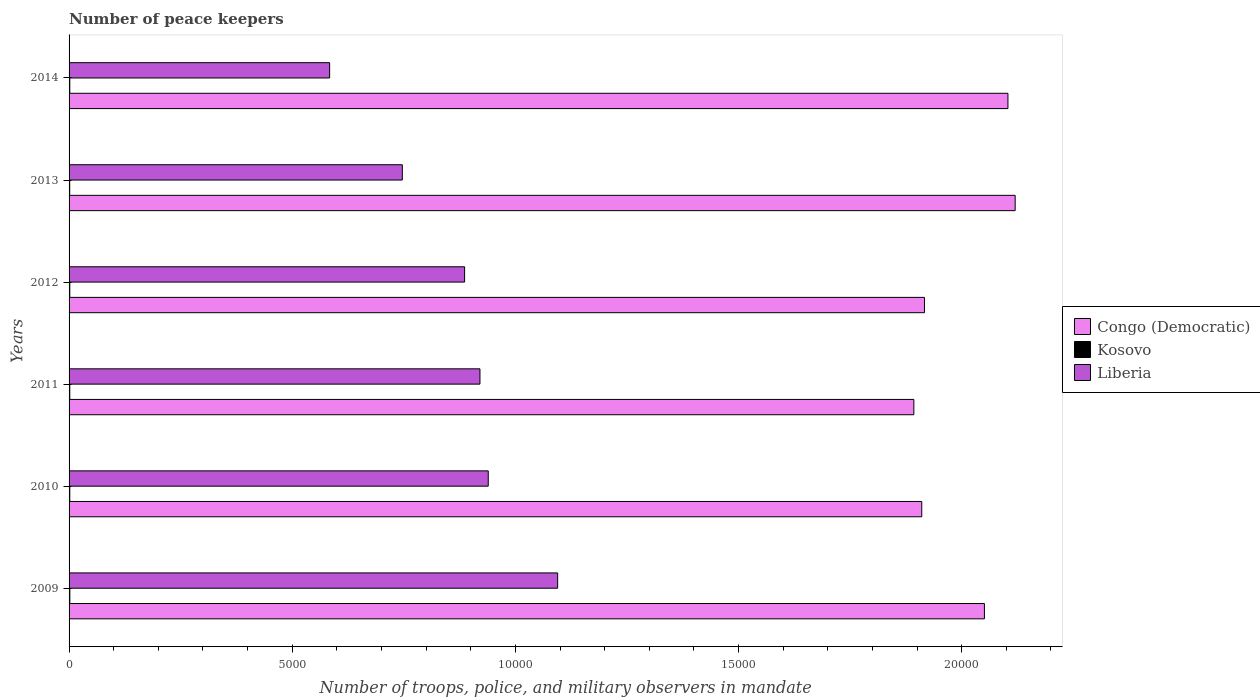Are the number of bars on each tick of the Y-axis equal?
Ensure brevity in your answer.  Yes. What is the label of the 6th group of bars from the top?
Keep it short and to the point. 2009. In how many cases, is the number of bars for a given year not equal to the number of legend labels?
Provide a succinct answer. 0. Across all years, what is the maximum number of peace keepers in in Congo (Democratic)?
Ensure brevity in your answer.  2.12e+04. Across all years, what is the minimum number of peace keepers in in Kosovo?
Offer a terse response. 14. What is the total number of peace keepers in in Kosovo in the graph?
Your response must be concise. 95. What is the difference between the number of peace keepers in in Liberia in 2009 and that in 2010?
Your answer should be compact. 1555. What is the difference between the number of peace keepers in in Liberia in 2011 and the number of peace keepers in in Congo (Democratic) in 2012?
Your answer should be compact. -9960. What is the average number of peace keepers in in Liberia per year?
Provide a succinct answer. 8618.67. In the year 2011, what is the difference between the number of peace keepers in in Kosovo and number of peace keepers in in Congo (Democratic)?
Offer a terse response. -1.89e+04. In how many years, is the number of peace keepers in in Kosovo greater than 9000 ?
Your answer should be compact. 0. What is the ratio of the number of peace keepers in in Kosovo in 2010 to that in 2013?
Your answer should be very brief. 1.14. Is the difference between the number of peace keepers in in Kosovo in 2009 and 2011 greater than the difference between the number of peace keepers in in Congo (Democratic) in 2009 and 2011?
Give a very brief answer. No. What is the difference between the highest and the lowest number of peace keepers in in Congo (Democratic)?
Make the answer very short. 2270. In how many years, is the number of peace keepers in in Congo (Democratic) greater than the average number of peace keepers in in Congo (Democratic) taken over all years?
Make the answer very short. 3. What does the 2nd bar from the top in 2013 represents?
Your answer should be very brief. Kosovo. What does the 2nd bar from the bottom in 2010 represents?
Provide a short and direct response. Kosovo. Is it the case that in every year, the sum of the number of peace keepers in in Congo (Democratic) and number of peace keepers in in Liberia is greater than the number of peace keepers in in Kosovo?
Your response must be concise. Yes. Are all the bars in the graph horizontal?
Provide a short and direct response. Yes. What is the difference between two consecutive major ticks on the X-axis?
Your response must be concise. 5000. Does the graph contain any zero values?
Offer a very short reply. No. What is the title of the graph?
Provide a succinct answer. Number of peace keepers. What is the label or title of the X-axis?
Your response must be concise. Number of troops, police, and military observers in mandate. What is the Number of troops, police, and military observers in mandate in Congo (Democratic) in 2009?
Provide a succinct answer. 2.05e+04. What is the Number of troops, police, and military observers in mandate in Liberia in 2009?
Ensure brevity in your answer.  1.09e+04. What is the Number of troops, police, and military observers in mandate of Congo (Democratic) in 2010?
Your answer should be compact. 1.91e+04. What is the Number of troops, police, and military observers in mandate in Kosovo in 2010?
Provide a succinct answer. 16. What is the Number of troops, police, and military observers in mandate of Liberia in 2010?
Give a very brief answer. 9392. What is the Number of troops, police, and military observers in mandate in Congo (Democratic) in 2011?
Give a very brief answer. 1.89e+04. What is the Number of troops, police, and military observers in mandate in Kosovo in 2011?
Ensure brevity in your answer.  16. What is the Number of troops, police, and military observers in mandate in Liberia in 2011?
Your answer should be very brief. 9206. What is the Number of troops, police, and military observers in mandate in Congo (Democratic) in 2012?
Your answer should be compact. 1.92e+04. What is the Number of troops, police, and military observers in mandate in Liberia in 2012?
Ensure brevity in your answer.  8862. What is the Number of troops, police, and military observers in mandate in Congo (Democratic) in 2013?
Your answer should be compact. 2.12e+04. What is the Number of troops, police, and military observers in mandate of Kosovo in 2013?
Your response must be concise. 14. What is the Number of troops, police, and military observers in mandate of Liberia in 2013?
Your answer should be very brief. 7467. What is the Number of troops, police, and military observers in mandate of Congo (Democratic) in 2014?
Keep it short and to the point. 2.10e+04. What is the Number of troops, police, and military observers in mandate in Kosovo in 2014?
Keep it short and to the point. 16. What is the Number of troops, police, and military observers in mandate in Liberia in 2014?
Provide a succinct answer. 5838. Across all years, what is the maximum Number of troops, police, and military observers in mandate of Congo (Democratic)?
Your answer should be compact. 2.12e+04. Across all years, what is the maximum Number of troops, police, and military observers in mandate of Kosovo?
Your answer should be very brief. 17. Across all years, what is the maximum Number of troops, police, and military observers in mandate of Liberia?
Offer a very short reply. 1.09e+04. Across all years, what is the minimum Number of troops, police, and military observers in mandate in Congo (Democratic)?
Your answer should be very brief. 1.89e+04. Across all years, what is the minimum Number of troops, police, and military observers in mandate of Liberia?
Offer a very short reply. 5838. What is the total Number of troops, police, and military observers in mandate in Congo (Democratic) in the graph?
Your answer should be compact. 1.20e+05. What is the total Number of troops, police, and military observers in mandate in Liberia in the graph?
Offer a very short reply. 5.17e+04. What is the difference between the Number of troops, police, and military observers in mandate in Congo (Democratic) in 2009 and that in 2010?
Offer a terse response. 1404. What is the difference between the Number of troops, police, and military observers in mandate of Liberia in 2009 and that in 2010?
Keep it short and to the point. 1555. What is the difference between the Number of troops, police, and military observers in mandate of Congo (Democratic) in 2009 and that in 2011?
Give a very brief answer. 1581. What is the difference between the Number of troops, police, and military observers in mandate of Kosovo in 2009 and that in 2011?
Keep it short and to the point. 1. What is the difference between the Number of troops, police, and military observers in mandate in Liberia in 2009 and that in 2011?
Give a very brief answer. 1741. What is the difference between the Number of troops, police, and military observers in mandate of Congo (Democratic) in 2009 and that in 2012?
Your response must be concise. 1343. What is the difference between the Number of troops, police, and military observers in mandate of Kosovo in 2009 and that in 2012?
Ensure brevity in your answer.  1. What is the difference between the Number of troops, police, and military observers in mandate in Liberia in 2009 and that in 2012?
Provide a short and direct response. 2085. What is the difference between the Number of troops, police, and military observers in mandate of Congo (Democratic) in 2009 and that in 2013?
Your answer should be very brief. -689. What is the difference between the Number of troops, police, and military observers in mandate of Liberia in 2009 and that in 2013?
Offer a very short reply. 3480. What is the difference between the Number of troops, police, and military observers in mandate in Congo (Democratic) in 2009 and that in 2014?
Keep it short and to the point. -527. What is the difference between the Number of troops, police, and military observers in mandate in Kosovo in 2009 and that in 2014?
Offer a terse response. 1. What is the difference between the Number of troops, police, and military observers in mandate of Liberia in 2009 and that in 2014?
Give a very brief answer. 5109. What is the difference between the Number of troops, police, and military observers in mandate of Congo (Democratic) in 2010 and that in 2011?
Keep it short and to the point. 177. What is the difference between the Number of troops, police, and military observers in mandate in Kosovo in 2010 and that in 2011?
Give a very brief answer. 0. What is the difference between the Number of troops, police, and military observers in mandate in Liberia in 2010 and that in 2011?
Provide a succinct answer. 186. What is the difference between the Number of troops, police, and military observers in mandate in Congo (Democratic) in 2010 and that in 2012?
Your response must be concise. -61. What is the difference between the Number of troops, police, and military observers in mandate in Liberia in 2010 and that in 2012?
Your response must be concise. 530. What is the difference between the Number of troops, police, and military observers in mandate in Congo (Democratic) in 2010 and that in 2013?
Your answer should be very brief. -2093. What is the difference between the Number of troops, police, and military observers in mandate of Liberia in 2010 and that in 2013?
Your answer should be compact. 1925. What is the difference between the Number of troops, police, and military observers in mandate of Congo (Democratic) in 2010 and that in 2014?
Offer a very short reply. -1931. What is the difference between the Number of troops, police, and military observers in mandate in Kosovo in 2010 and that in 2014?
Make the answer very short. 0. What is the difference between the Number of troops, police, and military observers in mandate in Liberia in 2010 and that in 2014?
Provide a succinct answer. 3554. What is the difference between the Number of troops, police, and military observers in mandate of Congo (Democratic) in 2011 and that in 2012?
Make the answer very short. -238. What is the difference between the Number of troops, police, and military observers in mandate in Kosovo in 2011 and that in 2012?
Give a very brief answer. 0. What is the difference between the Number of troops, police, and military observers in mandate in Liberia in 2011 and that in 2012?
Offer a very short reply. 344. What is the difference between the Number of troops, police, and military observers in mandate in Congo (Democratic) in 2011 and that in 2013?
Keep it short and to the point. -2270. What is the difference between the Number of troops, police, and military observers in mandate in Liberia in 2011 and that in 2013?
Your response must be concise. 1739. What is the difference between the Number of troops, police, and military observers in mandate of Congo (Democratic) in 2011 and that in 2014?
Offer a terse response. -2108. What is the difference between the Number of troops, police, and military observers in mandate in Kosovo in 2011 and that in 2014?
Provide a short and direct response. 0. What is the difference between the Number of troops, police, and military observers in mandate of Liberia in 2011 and that in 2014?
Your answer should be compact. 3368. What is the difference between the Number of troops, police, and military observers in mandate in Congo (Democratic) in 2012 and that in 2013?
Your response must be concise. -2032. What is the difference between the Number of troops, police, and military observers in mandate in Liberia in 2012 and that in 2013?
Keep it short and to the point. 1395. What is the difference between the Number of troops, police, and military observers in mandate of Congo (Democratic) in 2012 and that in 2014?
Provide a succinct answer. -1870. What is the difference between the Number of troops, police, and military observers in mandate of Kosovo in 2012 and that in 2014?
Provide a succinct answer. 0. What is the difference between the Number of troops, police, and military observers in mandate of Liberia in 2012 and that in 2014?
Your answer should be compact. 3024. What is the difference between the Number of troops, police, and military observers in mandate in Congo (Democratic) in 2013 and that in 2014?
Offer a terse response. 162. What is the difference between the Number of troops, police, and military observers in mandate of Liberia in 2013 and that in 2014?
Give a very brief answer. 1629. What is the difference between the Number of troops, police, and military observers in mandate in Congo (Democratic) in 2009 and the Number of troops, police, and military observers in mandate in Kosovo in 2010?
Offer a very short reply. 2.05e+04. What is the difference between the Number of troops, police, and military observers in mandate of Congo (Democratic) in 2009 and the Number of troops, police, and military observers in mandate of Liberia in 2010?
Keep it short and to the point. 1.11e+04. What is the difference between the Number of troops, police, and military observers in mandate in Kosovo in 2009 and the Number of troops, police, and military observers in mandate in Liberia in 2010?
Provide a short and direct response. -9375. What is the difference between the Number of troops, police, and military observers in mandate of Congo (Democratic) in 2009 and the Number of troops, police, and military observers in mandate of Kosovo in 2011?
Provide a short and direct response. 2.05e+04. What is the difference between the Number of troops, police, and military observers in mandate of Congo (Democratic) in 2009 and the Number of troops, police, and military observers in mandate of Liberia in 2011?
Offer a very short reply. 1.13e+04. What is the difference between the Number of troops, police, and military observers in mandate in Kosovo in 2009 and the Number of troops, police, and military observers in mandate in Liberia in 2011?
Make the answer very short. -9189. What is the difference between the Number of troops, police, and military observers in mandate of Congo (Democratic) in 2009 and the Number of troops, police, and military observers in mandate of Kosovo in 2012?
Ensure brevity in your answer.  2.05e+04. What is the difference between the Number of troops, police, and military observers in mandate of Congo (Democratic) in 2009 and the Number of troops, police, and military observers in mandate of Liberia in 2012?
Offer a very short reply. 1.16e+04. What is the difference between the Number of troops, police, and military observers in mandate in Kosovo in 2009 and the Number of troops, police, and military observers in mandate in Liberia in 2012?
Give a very brief answer. -8845. What is the difference between the Number of troops, police, and military observers in mandate of Congo (Democratic) in 2009 and the Number of troops, police, and military observers in mandate of Kosovo in 2013?
Ensure brevity in your answer.  2.05e+04. What is the difference between the Number of troops, police, and military observers in mandate in Congo (Democratic) in 2009 and the Number of troops, police, and military observers in mandate in Liberia in 2013?
Offer a terse response. 1.30e+04. What is the difference between the Number of troops, police, and military observers in mandate of Kosovo in 2009 and the Number of troops, police, and military observers in mandate of Liberia in 2013?
Provide a short and direct response. -7450. What is the difference between the Number of troops, police, and military observers in mandate in Congo (Democratic) in 2009 and the Number of troops, police, and military observers in mandate in Kosovo in 2014?
Your answer should be very brief. 2.05e+04. What is the difference between the Number of troops, police, and military observers in mandate in Congo (Democratic) in 2009 and the Number of troops, police, and military observers in mandate in Liberia in 2014?
Your answer should be very brief. 1.47e+04. What is the difference between the Number of troops, police, and military observers in mandate of Kosovo in 2009 and the Number of troops, police, and military observers in mandate of Liberia in 2014?
Give a very brief answer. -5821. What is the difference between the Number of troops, police, and military observers in mandate in Congo (Democratic) in 2010 and the Number of troops, police, and military observers in mandate in Kosovo in 2011?
Keep it short and to the point. 1.91e+04. What is the difference between the Number of troops, police, and military observers in mandate in Congo (Democratic) in 2010 and the Number of troops, police, and military observers in mandate in Liberia in 2011?
Your response must be concise. 9899. What is the difference between the Number of troops, police, and military observers in mandate in Kosovo in 2010 and the Number of troops, police, and military observers in mandate in Liberia in 2011?
Your response must be concise. -9190. What is the difference between the Number of troops, police, and military observers in mandate in Congo (Democratic) in 2010 and the Number of troops, police, and military observers in mandate in Kosovo in 2012?
Keep it short and to the point. 1.91e+04. What is the difference between the Number of troops, police, and military observers in mandate of Congo (Democratic) in 2010 and the Number of troops, police, and military observers in mandate of Liberia in 2012?
Offer a very short reply. 1.02e+04. What is the difference between the Number of troops, police, and military observers in mandate in Kosovo in 2010 and the Number of troops, police, and military observers in mandate in Liberia in 2012?
Provide a short and direct response. -8846. What is the difference between the Number of troops, police, and military observers in mandate of Congo (Democratic) in 2010 and the Number of troops, police, and military observers in mandate of Kosovo in 2013?
Ensure brevity in your answer.  1.91e+04. What is the difference between the Number of troops, police, and military observers in mandate of Congo (Democratic) in 2010 and the Number of troops, police, and military observers in mandate of Liberia in 2013?
Your answer should be compact. 1.16e+04. What is the difference between the Number of troops, police, and military observers in mandate of Kosovo in 2010 and the Number of troops, police, and military observers in mandate of Liberia in 2013?
Your answer should be compact. -7451. What is the difference between the Number of troops, police, and military observers in mandate of Congo (Democratic) in 2010 and the Number of troops, police, and military observers in mandate of Kosovo in 2014?
Your response must be concise. 1.91e+04. What is the difference between the Number of troops, police, and military observers in mandate of Congo (Democratic) in 2010 and the Number of troops, police, and military observers in mandate of Liberia in 2014?
Give a very brief answer. 1.33e+04. What is the difference between the Number of troops, police, and military observers in mandate of Kosovo in 2010 and the Number of troops, police, and military observers in mandate of Liberia in 2014?
Offer a terse response. -5822. What is the difference between the Number of troops, police, and military observers in mandate in Congo (Democratic) in 2011 and the Number of troops, police, and military observers in mandate in Kosovo in 2012?
Provide a succinct answer. 1.89e+04. What is the difference between the Number of troops, police, and military observers in mandate in Congo (Democratic) in 2011 and the Number of troops, police, and military observers in mandate in Liberia in 2012?
Keep it short and to the point. 1.01e+04. What is the difference between the Number of troops, police, and military observers in mandate of Kosovo in 2011 and the Number of troops, police, and military observers in mandate of Liberia in 2012?
Your answer should be very brief. -8846. What is the difference between the Number of troops, police, and military observers in mandate in Congo (Democratic) in 2011 and the Number of troops, police, and military observers in mandate in Kosovo in 2013?
Your answer should be very brief. 1.89e+04. What is the difference between the Number of troops, police, and military observers in mandate in Congo (Democratic) in 2011 and the Number of troops, police, and military observers in mandate in Liberia in 2013?
Provide a succinct answer. 1.15e+04. What is the difference between the Number of troops, police, and military observers in mandate of Kosovo in 2011 and the Number of troops, police, and military observers in mandate of Liberia in 2013?
Give a very brief answer. -7451. What is the difference between the Number of troops, police, and military observers in mandate in Congo (Democratic) in 2011 and the Number of troops, police, and military observers in mandate in Kosovo in 2014?
Offer a very short reply. 1.89e+04. What is the difference between the Number of troops, police, and military observers in mandate in Congo (Democratic) in 2011 and the Number of troops, police, and military observers in mandate in Liberia in 2014?
Your response must be concise. 1.31e+04. What is the difference between the Number of troops, police, and military observers in mandate of Kosovo in 2011 and the Number of troops, police, and military observers in mandate of Liberia in 2014?
Provide a succinct answer. -5822. What is the difference between the Number of troops, police, and military observers in mandate of Congo (Democratic) in 2012 and the Number of troops, police, and military observers in mandate of Kosovo in 2013?
Give a very brief answer. 1.92e+04. What is the difference between the Number of troops, police, and military observers in mandate of Congo (Democratic) in 2012 and the Number of troops, police, and military observers in mandate of Liberia in 2013?
Keep it short and to the point. 1.17e+04. What is the difference between the Number of troops, police, and military observers in mandate in Kosovo in 2012 and the Number of troops, police, and military observers in mandate in Liberia in 2013?
Make the answer very short. -7451. What is the difference between the Number of troops, police, and military observers in mandate in Congo (Democratic) in 2012 and the Number of troops, police, and military observers in mandate in Kosovo in 2014?
Ensure brevity in your answer.  1.92e+04. What is the difference between the Number of troops, police, and military observers in mandate in Congo (Democratic) in 2012 and the Number of troops, police, and military observers in mandate in Liberia in 2014?
Offer a terse response. 1.33e+04. What is the difference between the Number of troops, police, and military observers in mandate of Kosovo in 2012 and the Number of troops, police, and military observers in mandate of Liberia in 2014?
Keep it short and to the point. -5822. What is the difference between the Number of troops, police, and military observers in mandate in Congo (Democratic) in 2013 and the Number of troops, police, and military observers in mandate in Kosovo in 2014?
Keep it short and to the point. 2.12e+04. What is the difference between the Number of troops, police, and military observers in mandate in Congo (Democratic) in 2013 and the Number of troops, police, and military observers in mandate in Liberia in 2014?
Provide a succinct answer. 1.54e+04. What is the difference between the Number of troops, police, and military observers in mandate of Kosovo in 2013 and the Number of troops, police, and military observers in mandate of Liberia in 2014?
Give a very brief answer. -5824. What is the average Number of troops, police, and military observers in mandate in Congo (Democratic) per year?
Your response must be concise. 2.00e+04. What is the average Number of troops, police, and military observers in mandate of Kosovo per year?
Give a very brief answer. 15.83. What is the average Number of troops, police, and military observers in mandate of Liberia per year?
Make the answer very short. 8618.67. In the year 2009, what is the difference between the Number of troops, police, and military observers in mandate of Congo (Democratic) and Number of troops, police, and military observers in mandate of Kosovo?
Offer a very short reply. 2.05e+04. In the year 2009, what is the difference between the Number of troops, police, and military observers in mandate of Congo (Democratic) and Number of troops, police, and military observers in mandate of Liberia?
Offer a terse response. 9562. In the year 2009, what is the difference between the Number of troops, police, and military observers in mandate of Kosovo and Number of troops, police, and military observers in mandate of Liberia?
Offer a terse response. -1.09e+04. In the year 2010, what is the difference between the Number of troops, police, and military observers in mandate in Congo (Democratic) and Number of troops, police, and military observers in mandate in Kosovo?
Make the answer very short. 1.91e+04. In the year 2010, what is the difference between the Number of troops, police, and military observers in mandate in Congo (Democratic) and Number of troops, police, and military observers in mandate in Liberia?
Keep it short and to the point. 9713. In the year 2010, what is the difference between the Number of troops, police, and military observers in mandate in Kosovo and Number of troops, police, and military observers in mandate in Liberia?
Your answer should be very brief. -9376. In the year 2011, what is the difference between the Number of troops, police, and military observers in mandate of Congo (Democratic) and Number of troops, police, and military observers in mandate of Kosovo?
Provide a succinct answer. 1.89e+04. In the year 2011, what is the difference between the Number of troops, police, and military observers in mandate in Congo (Democratic) and Number of troops, police, and military observers in mandate in Liberia?
Your answer should be very brief. 9722. In the year 2011, what is the difference between the Number of troops, police, and military observers in mandate of Kosovo and Number of troops, police, and military observers in mandate of Liberia?
Offer a terse response. -9190. In the year 2012, what is the difference between the Number of troops, police, and military observers in mandate in Congo (Democratic) and Number of troops, police, and military observers in mandate in Kosovo?
Offer a terse response. 1.92e+04. In the year 2012, what is the difference between the Number of troops, police, and military observers in mandate in Congo (Democratic) and Number of troops, police, and military observers in mandate in Liberia?
Offer a terse response. 1.03e+04. In the year 2012, what is the difference between the Number of troops, police, and military observers in mandate of Kosovo and Number of troops, police, and military observers in mandate of Liberia?
Your response must be concise. -8846. In the year 2013, what is the difference between the Number of troops, police, and military observers in mandate of Congo (Democratic) and Number of troops, police, and military observers in mandate of Kosovo?
Your response must be concise. 2.12e+04. In the year 2013, what is the difference between the Number of troops, police, and military observers in mandate of Congo (Democratic) and Number of troops, police, and military observers in mandate of Liberia?
Your answer should be compact. 1.37e+04. In the year 2013, what is the difference between the Number of troops, police, and military observers in mandate in Kosovo and Number of troops, police, and military observers in mandate in Liberia?
Ensure brevity in your answer.  -7453. In the year 2014, what is the difference between the Number of troops, police, and military observers in mandate in Congo (Democratic) and Number of troops, police, and military observers in mandate in Kosovo?
Offer a terse response. 2.10e+04. In the year 2014, what is the difference between the Number of troops, police, and military observers in mandate of Congo (Democratic) and Number of troops, police, and military observers in mandate of Liberia?
Provide a short and direct response. 1.52e+04. In the year 2014, what is the difference between the Number of troops, police, and military observers in mandate of Kosovo and Number of troops, police, and military observers in mandate of Liberia?
Offer a terse response. -5822. What is the ratio of the Number of troops, police, and military observers in mandate of Congo (Democratic) in 2009 to that in 2010?
Provide a succinct answer. 1.07. What is the ratio of the Number of troops, police, and military observers in mandate of Liberia in 2009 to that in 2010?
Give a very brief answer. 1.17. What is the ratio of the Number of troops, police, and military observers in mandate of Congo (Democratic) in 2009 to that in 2011?
Ensure brevity in your answer.  1.08. What is the ratio of the Number of troops, police, and military observers in mandate of Kosovo in 2009 to that in 2011?
Ensure brevity in your answer.  1.06. What is the ratio of the Number of troops, police, and military observers in mandate in Liberia in 2009 to that in 2011?
Ensure brevity in your answer.  1.19. What is the ratio of the Number of troops, police, and military observers in mandate of Congo (Democratic) in 2009 to that in 2012?
Keep it short and to the point. 1.07. What is the ratio of the Number of troops, police, and military observers in mandate in Kosovo in 2009 to that in 2012?
Your answer should be compact. 1.06. What is the ratio of the Number of troops, police, and military observers in mandate of Liberia in 2009 to that in 2012?
Keep it short and to the point. 1.24. What is the ratio of the Number of troops, police, and military observers in mandate in Congo (Democratic) in 2009 to that in 2013?
Your response must be concise. 0.97. What is the ratio of the Number of troops, police, and military observers in mandate of Kosovo in 2009 to that in 2013?
Offer a very short reply. 1.21. What is the ratio of the Number of troops, police, and military observers in mandate of Liberia in 2009 to that in 2013?
Your answer should be compact. 1.47. What is the ratio of the Number of troops, police, and military observers in mandate of Congo (Democratic) in 2009 to that in 2014?
Offer a very short reply. 0.97. What is the ratio of the Number of troops, police, and military observers in mandate in Liberia in 2009 to that in 2014?
Keep it short and to the point. 1.88. What is the ratio of the Number of troops, police, and military observers in mandate in Congo (Democratic) in 2010 to that in 2011?
Ensure brevity in your answer.  1.01. What is the ratio of the Number of troops, police, and military observers in mandate in Liberia in 2010 to that in 2011?
Provide a succinct answer. 1.02. What is the ratio of the Number of troops, police, and military observers in mandate in Congo (Democratic) in 2010 to that in 2012?
Provide a succinct answer. 1. What is the ratio of the Number of troops, police, and military observers in mandate of Liberia in 2010 to that in 2012?
Offer a very short reply. 1.06. What is the ratio of the Number of troops, police, and military observers in mandate of Congo (Democratic) in 2010 to that in 2013?
Provide a succinct answer. 0.9. What is the ratio of the Number of troops, police, and military observers in mandate of Kosovo in 2010 to that in 2013?
Offer a terse response. 1.14. What is the ratio of the Number of troops, police, and military observers in mandate in Liberia in 2010 to that in 2013?
Your answer should be compact. 1.26. What is the ratio of the Number of troops, police, and military observers in mandate of Congo (Democratic) in 2010 to that in 2014?
Provide a succinct answer. 0.91. What is the ratio of the Number of troops, police, and military observers in mandate in Kosovo in 2010 to that in 2014?
Ensure brevity in your answer.  1. What is the ratio of the Number of troops, police, and military observers in mandate of Liberia in 2010 to that in 2014?
Ensure brevity in your answer.  1.61. What is the ratio of the Number of troops, police, and military observers in mandate of Congo (Democratic) in 2011 to that in 2012?
Provide a short and direct response. 0.99. What is the ratio of the Number of troops, police, and military observers in mandate in Kosovo in 2011 to that in 2012?
Make the answer very short. 1. What is the ratio of the Number of troops, police, and military observers in mandate of Liberia in 2011 to that in 2012?
Make the answer very short. 1.04. What is the ratio of the Number of troops, police, and military observers in mandate of Congo (Democratic) in 2011 to that in 2013?
Make the answer very short. 0.89. What is the ratio of the Number of troops, police, and military observers in mandate of Kosovo in 2011 to that in 2013?
Offer a terse response. 1.14. What is the ratio of the Number of troops, police, and military observers in mandate in Liberia in 2011 to that in 2013?
Your answer should be compact. 1.23. What is the ratio of the Number of troops, police, and military observers in mandate of Congo (Democratic) in 2011 to that in 2014?
Your answer should be compact. 0.9. What is the ratio of the Number of troops, police, and military observers in mandate in Liberia in 2011 to that in 2014?
Your response must be concise. 1.58. What is the ratio of the Number of troops, police, and military observers in mandate of Congo (Democratic) in 2012 to that in 2013?
Make the answer very short. 0.9. What is the ratio of the Number of troops, police, and military observers in mandate in Kosovo in 2012 to that in 2013?
Keep it short and to the point. 1.14. What is the ratio of the Number of troops, police, and military observers in mandate of Liberia in 2012 to that in 2013?
Provide a short and direct response. 1.19. What is the ratio of the Number of troops, police, and military observers in mandate of Congo (Democratic) in 2012 to that in 2014?
Your answer should be very brief. 0.91. What is the ratio of the Number of troops, police, and military observers in mandate in Liberia in 2012 to that in 2014?
Make the answer very short. 1.52. What is the ratio of the Number of troops, police, and military observers in mandate in Congo (Democratic) in 2013 to that in 2014?
Ensure brevity in your answer.  1.01. What is the ratio of the Number of troops, police, and military observers in mandate in Kosovo in 2013 to that in 2014?
Keep it short and to the point. 0.88. What is the ratio of the Number of troops, police, and military observers in mandate of Liberia in 2013 to that in 2014?
Your response must be concise. 1.28. What is the difference between the highest and the second highest Number of troops, police, and military observers in mandate in Congo (Democratic)?
Offer a terse response. 162. What is the difference between the highest and the second highest Number of troops, police, and military observers in mandate in Kosovo?
Make the answer very short. 1. What is the difference between the highest and the second highest Number of troops, police, and military observers in mandate of Liberia?
Make the answer very short. 1555. What is the difference between the highest and the lowest Number of troops, police, and military observers in mandate in Congo (Democratic)?
Make the answer very short. 2270. What is the difference between the highest and the lowest Number of troops, police, and military observers in mandate of Kosovo?
Provide a short and direct response. 3. What is the difference between the highest and the lowest Number of troops, police, and military observers in mandate of Liberia?
Ensure brevity in your answer.  5109. 